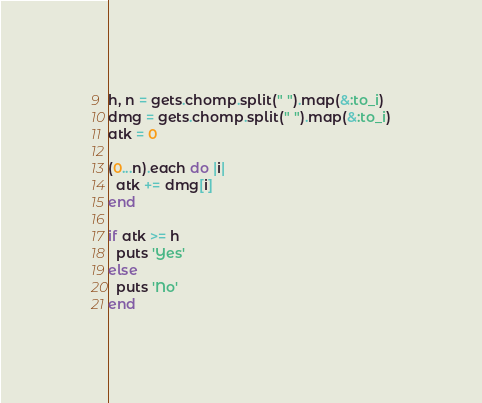Convert code to text. <code><loc_0><loc_0><loc_500><loc_500><_Ruby_>h, n = gets.chomp.split(" ").map(&:to_i)
dmg = gets.chomp.split(" ").map(&:to_i)
atk = 0

(0...n).each do |i|
  atk += dmg[i]
end

if atk >= h
  puts 'Yes'
else
  puts 'No'
end</code> 